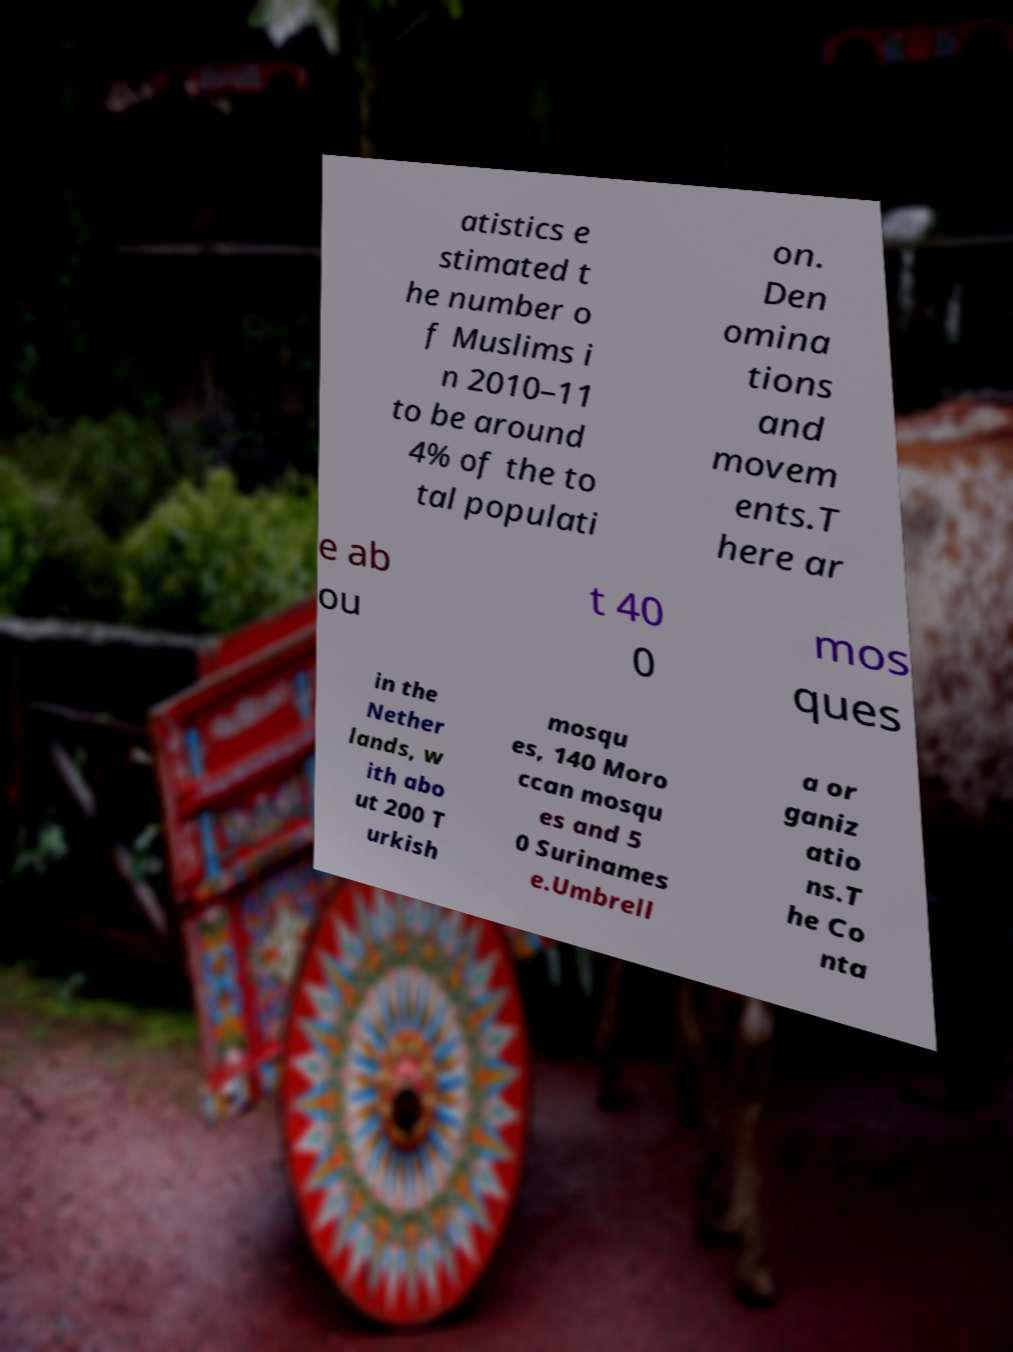I need the written content from this picture converted into text. Can you do that? atistics e stimated t he number o f Muslims i n 2010–11 to be around 4% of the to tal populati on. Den omina tions and movem ents.T here ar e ab ou t 40 0 mos ques in the Nether lands, w ith abo ut 200 T urkish mosqu es, 140 Moro ccan mosqu es and 5 0 Surinames e.Umbrell a or ganiz atio ns.T he Co nta 